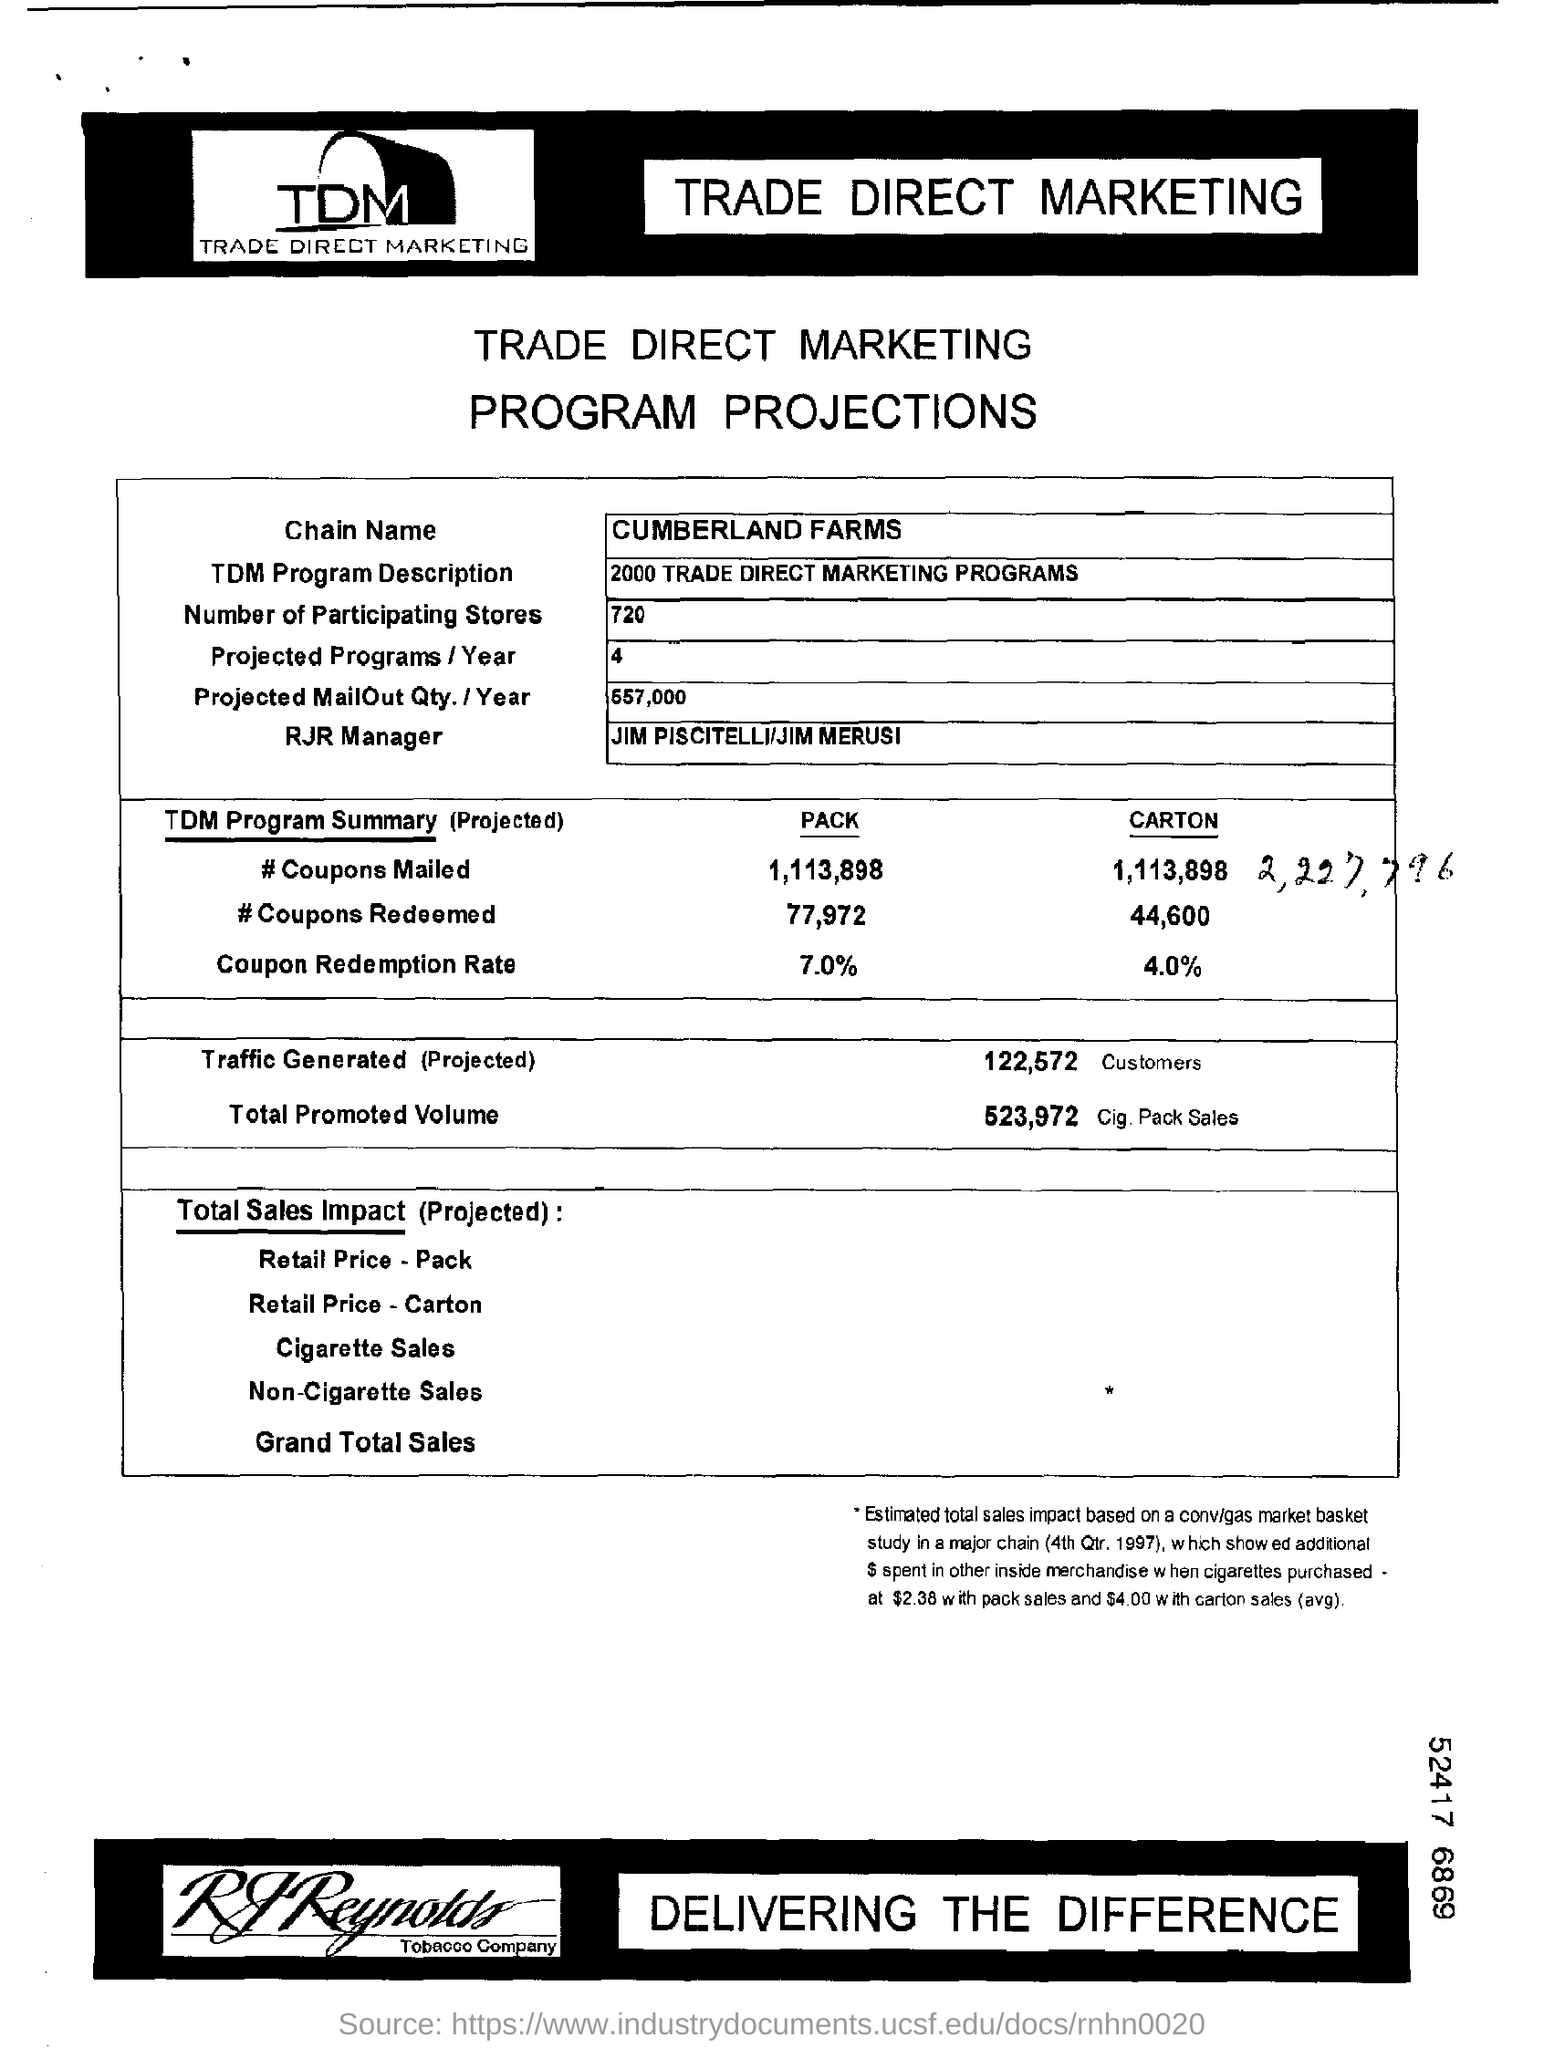What is tdm program description ?
Provide a short and direct response. 2000 TRADE DIRECT MARKETING PROGRAMS. How many participating stores are ?
Ensure brevity in your answer.  720. Who is rjr manager ?
Make the answer very short. Jim piscitelli / jim merusi. 